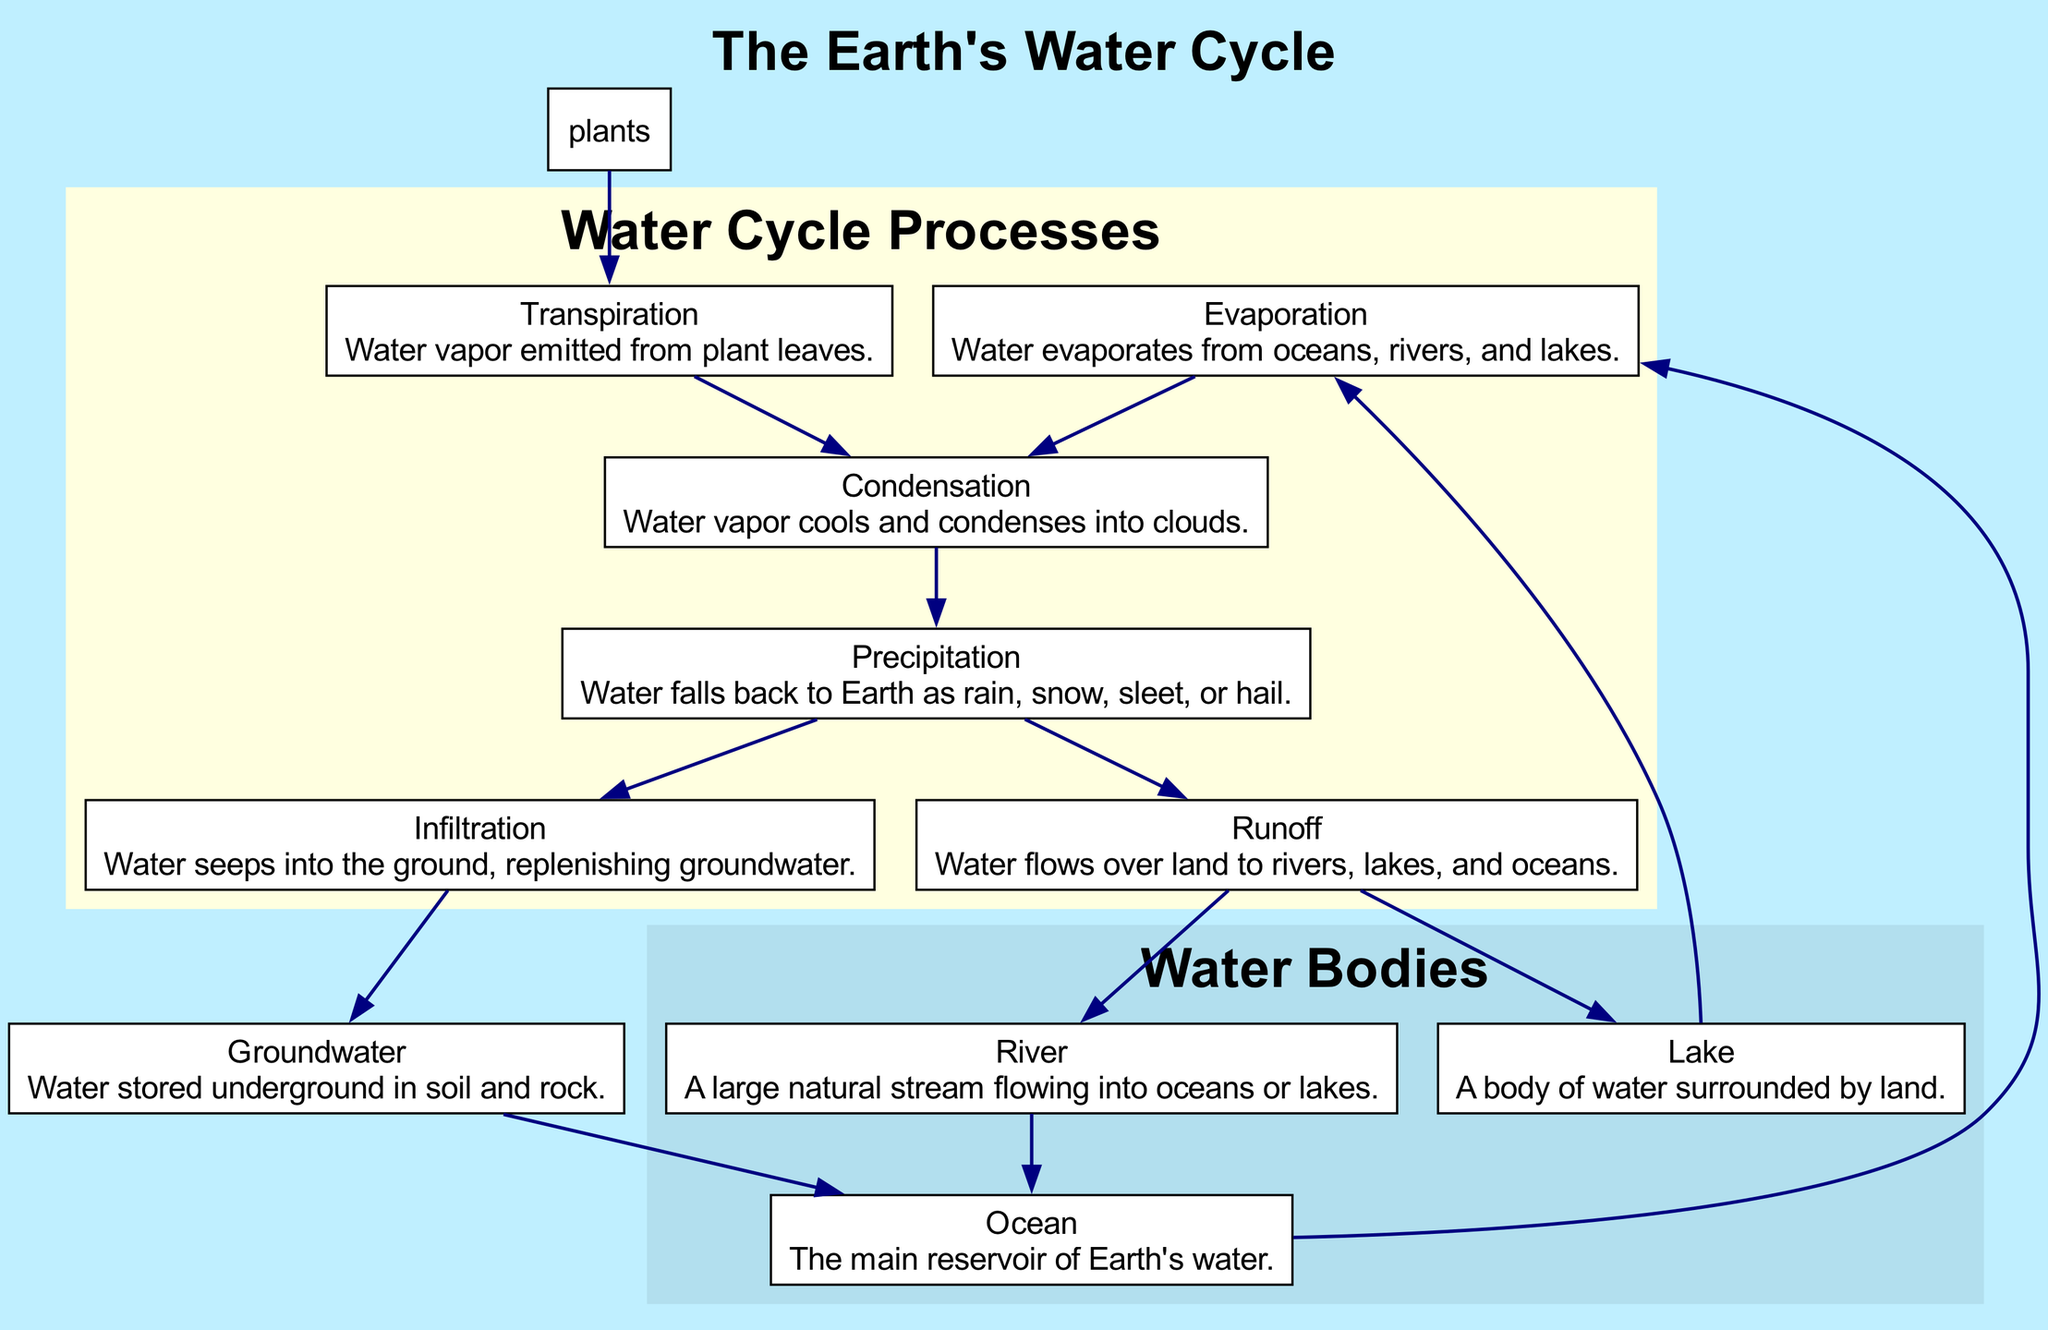What is the main reservoir of Earth's water? The diagram indicates that the "Ocean" is identified as the main reservoir of Earth's water. This can be seen directly in the node descriptions where "Ocean" is listed.
Answer: Ocean Which process follows evaporation? According to the flow of the diagram, the process that comes after "Evaporation" is "Condensation". This relationship is indicated by a directed edge from the evaporation node to the condensation node.
Answer: Condensation How many major processes are depicted in the water cycle? The diagram outlines six major processes: evaporation, condensation, precipitation, infiltration, runoff, and transpiration. Counting these nodes shows that there are six significant processes identified.
Answer: Six What happens to water after precipitation? The diagram depicts two possible paths for water after "Precipitation": it can either infiltrate into the ground or create runoff to flow over land. This is indicated through the outgoing edges from the precipitation node.
Answer: Infiltration and Runoff Which node represents water stored underground? In the diagram, the node labeled "Groundwater" specifically represents water stored underground in soil and rock. This can be confirmed by looking at the node descriptions where "Groundwater" is explained.
Answer: Groundwater If precipitation leads to runoff, where does that runoff ultimately flow? The diagram shows that "Runoff" can flow to both "Lakes" and "Rivers," which then lead to the "Ocean." This is outlined within the edges leading away from the runoff node.
Answer: Lakes and Rivers What process is responsible for water vapor emission from plants? The process known as "Transpiration" is responsible for the emission of water vapor from plant leaves as depicted in the diagram. This is verified by the specific labeling and description associated with the transpiration node.
Answer: Transpiration What indicates that water returns to the ocean from groundwater? The directed edge from "Groundwater" to "Ocean" in the diagram signifies that water stored underground can eventually return to the ocean. This relationship is clearly marked, showing the flow back to the ocean.
Answer: Ocean 